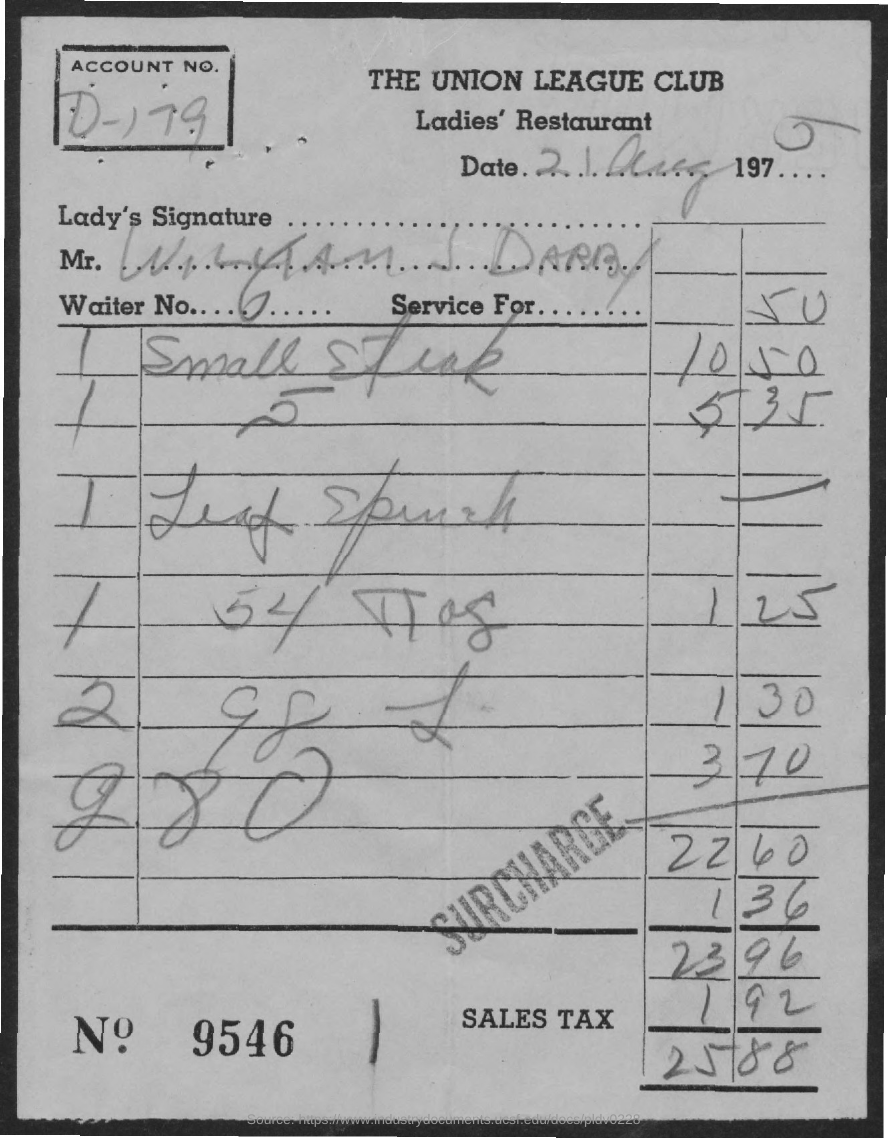What is the account no.?
Ensure brevity in your answer.  D-179. What is the waiter no. ?
Give a very brief answer. 6. What is the date on bill?
Provide a short and direct response. 21 Aug 1975. What is the bill no.?
Make the answer very short. 9546. What is the sales tax charged?
Your answer should be compact. 192. What is the total amount?
Provide a short and direct response. 25.88. 